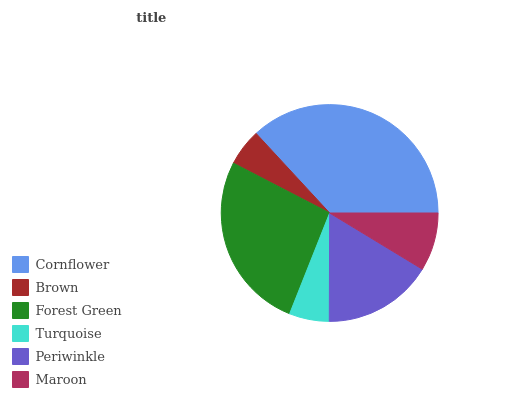Is Brown the minimum?
Answer yes or no. Yes. Is Cornflower the maximum?
Answer yes or no. Yes. Is Forest Green the minimum?
Answer yes or no. No. Is Forest Green the maximum?
Answer yes or no. No. Is Forest Green greater than Brown?
Answer yes or no. Yes. Is Brown less than Forest Green?
Answer yes or no. Yes. Is Brown greater than Forest Green?
Answer yes or no. No. Is Forest Green less than Brown?
Answer yes or no. No. Is Periwinkle the high median?
Answer yes or no. Yes. Is Maroon the low median?
Answer yes or no. Yes. Is Brown the high median?
Answer yes or no. No. Is Forest Green the low median?
Answer yes or no. No. 